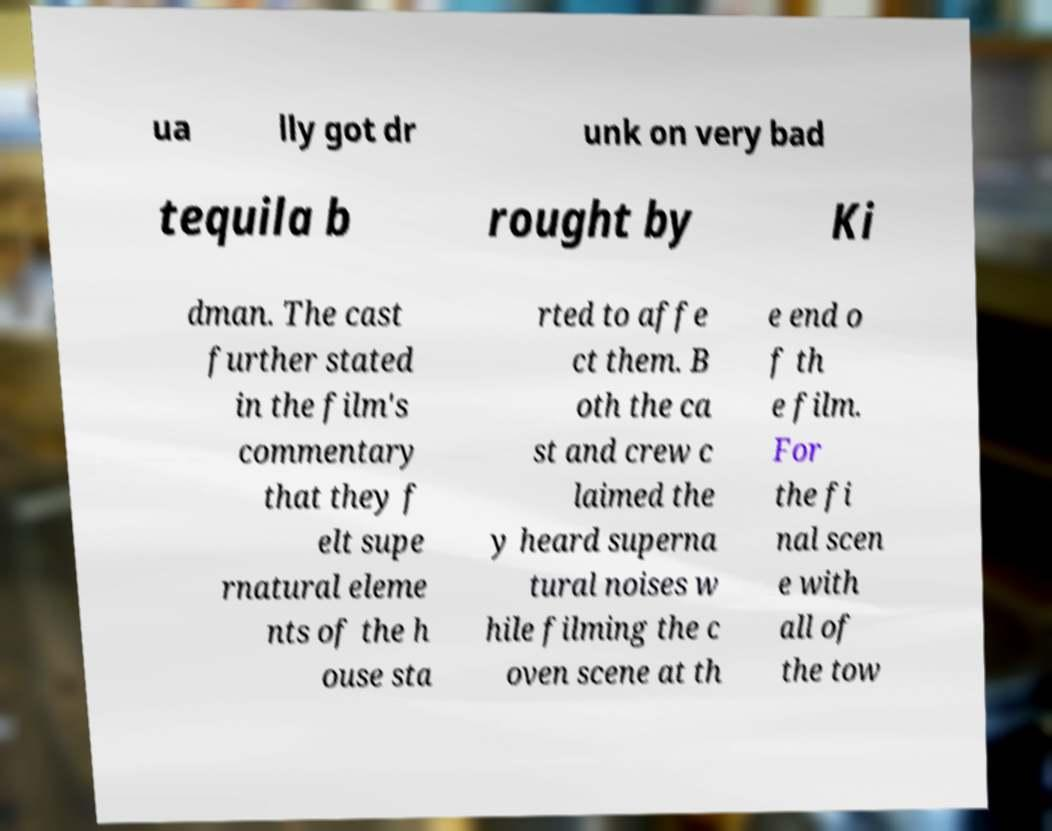Could you assist in decoding the text presented in this image and type it out clearly? ua lly got dr unk on very bad tequila b rought by Ki dman. The cast further stated in the film's commentary that they f elt supe rnatural eleme nts of the h ouse sta rted to affe ct them. B oth the ca st and crew c laimed the y heard superna tural noises w hile filming the c oven scene at th e end o f th e film. For the fi nal scen e with all of the tow 